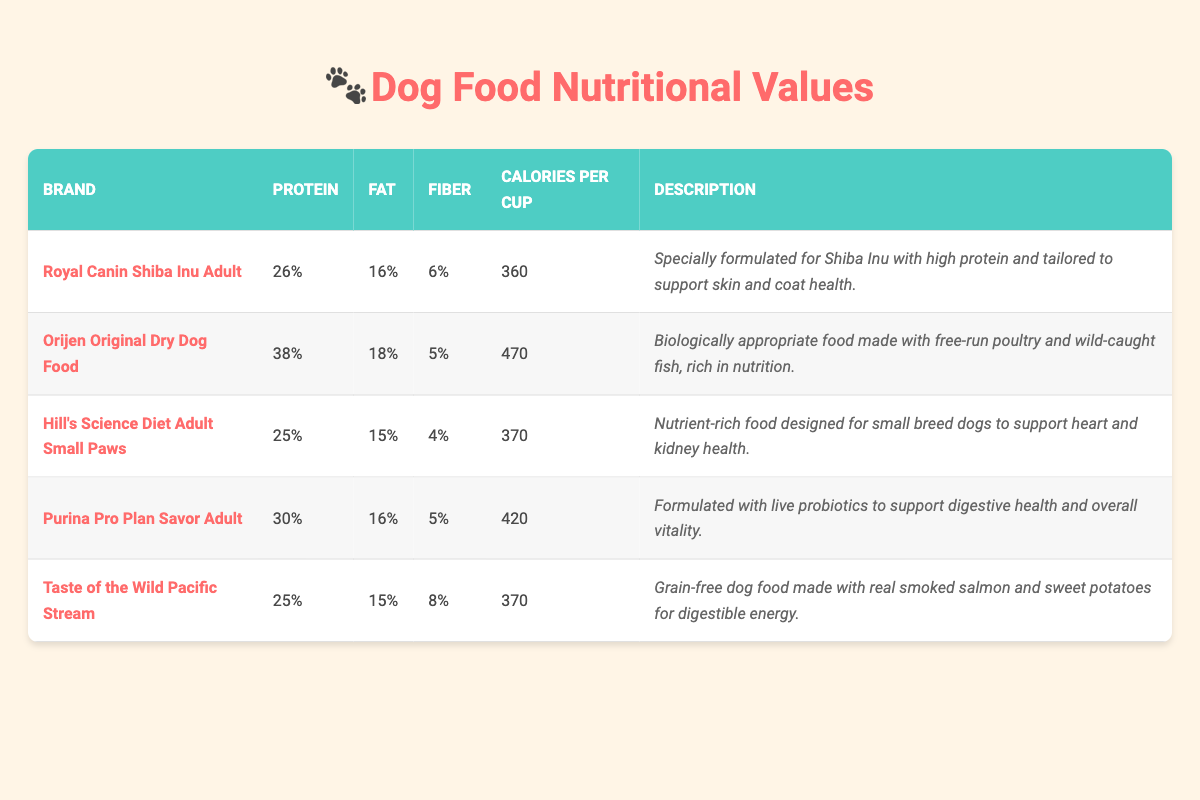What is the protein content of Royal Canin Shiba Inu Adult? The table lists the protein content for each brand of dog food. For Royal Canin Shiba Inu Adult, the protein content is specified as 26%.
Answer: 26% Which dog food brand has the highest fat percentage? By looking at the fat percentage column, we see that Orijen Original Dry Dog Food has 18%, which is the highest compared to other brands.
Answer: Orijen Original Dry Dog Food Is the fiber content for Purina Pro Plan Savor Adult greater than that of Hill's Science Diet Adult Small Paws? The fiber content for Purina Pro Plan Savor Adult is 5%, while the fiber content for Hill's Science Diet Adult Small Paws is 4%. Since 5% is greater than 4%, the statement is true.
Answer: Yes What is the average calories per cup for the dog food brands listed? To find the average, we sum the calories per cup: (360 + 470 + 370 + 420 + 370) = 1990. Then, we divide this sum by the number of brands, which is 5. So, 1990 / 5 = 398.
Answer: 398 Does Taste of the Wild Pacific Stream provide more fiber than Royal Canin Shiba Inu Adult? Taste of the Wild Pacific Stream has 8% fiber, while Royal Canin Shiba Inu Adult has 6%. Since 8% is greater than 6%, the answer is yes.
Answer: Yes Which brand has the lowest protein content? Looking at the protein percentage for each brand, Hill's Science Diet Adult Small Paws has the lowest at 25%.
Answer: Hill's Science Diet Adult Small Paws What is the total fat percentage of Purina Pro Plan Savor Adult compared to Orijen Original Dry Dog Food? The fat percentage for Purina Pro Plan Savor Adult is 16%, while for Orijen Original Dry Dog Food, it is 18%. So, 16% is less than 18%.
Answer: Purina Pro Plan Savor Adult Which dog food brand is specifically formulated for Shiba Inus, and what is its description? The table states that Royal Canin Shiba Inu Adult is specifically formulated for Shiba Inus, and its description highlights it as specially formulated to support skin and coat health.
Answer: Royal Canin Shiba Inu Adult; Specially formulated for Shiba Inu with high protein and tailored to support skin and coat health 